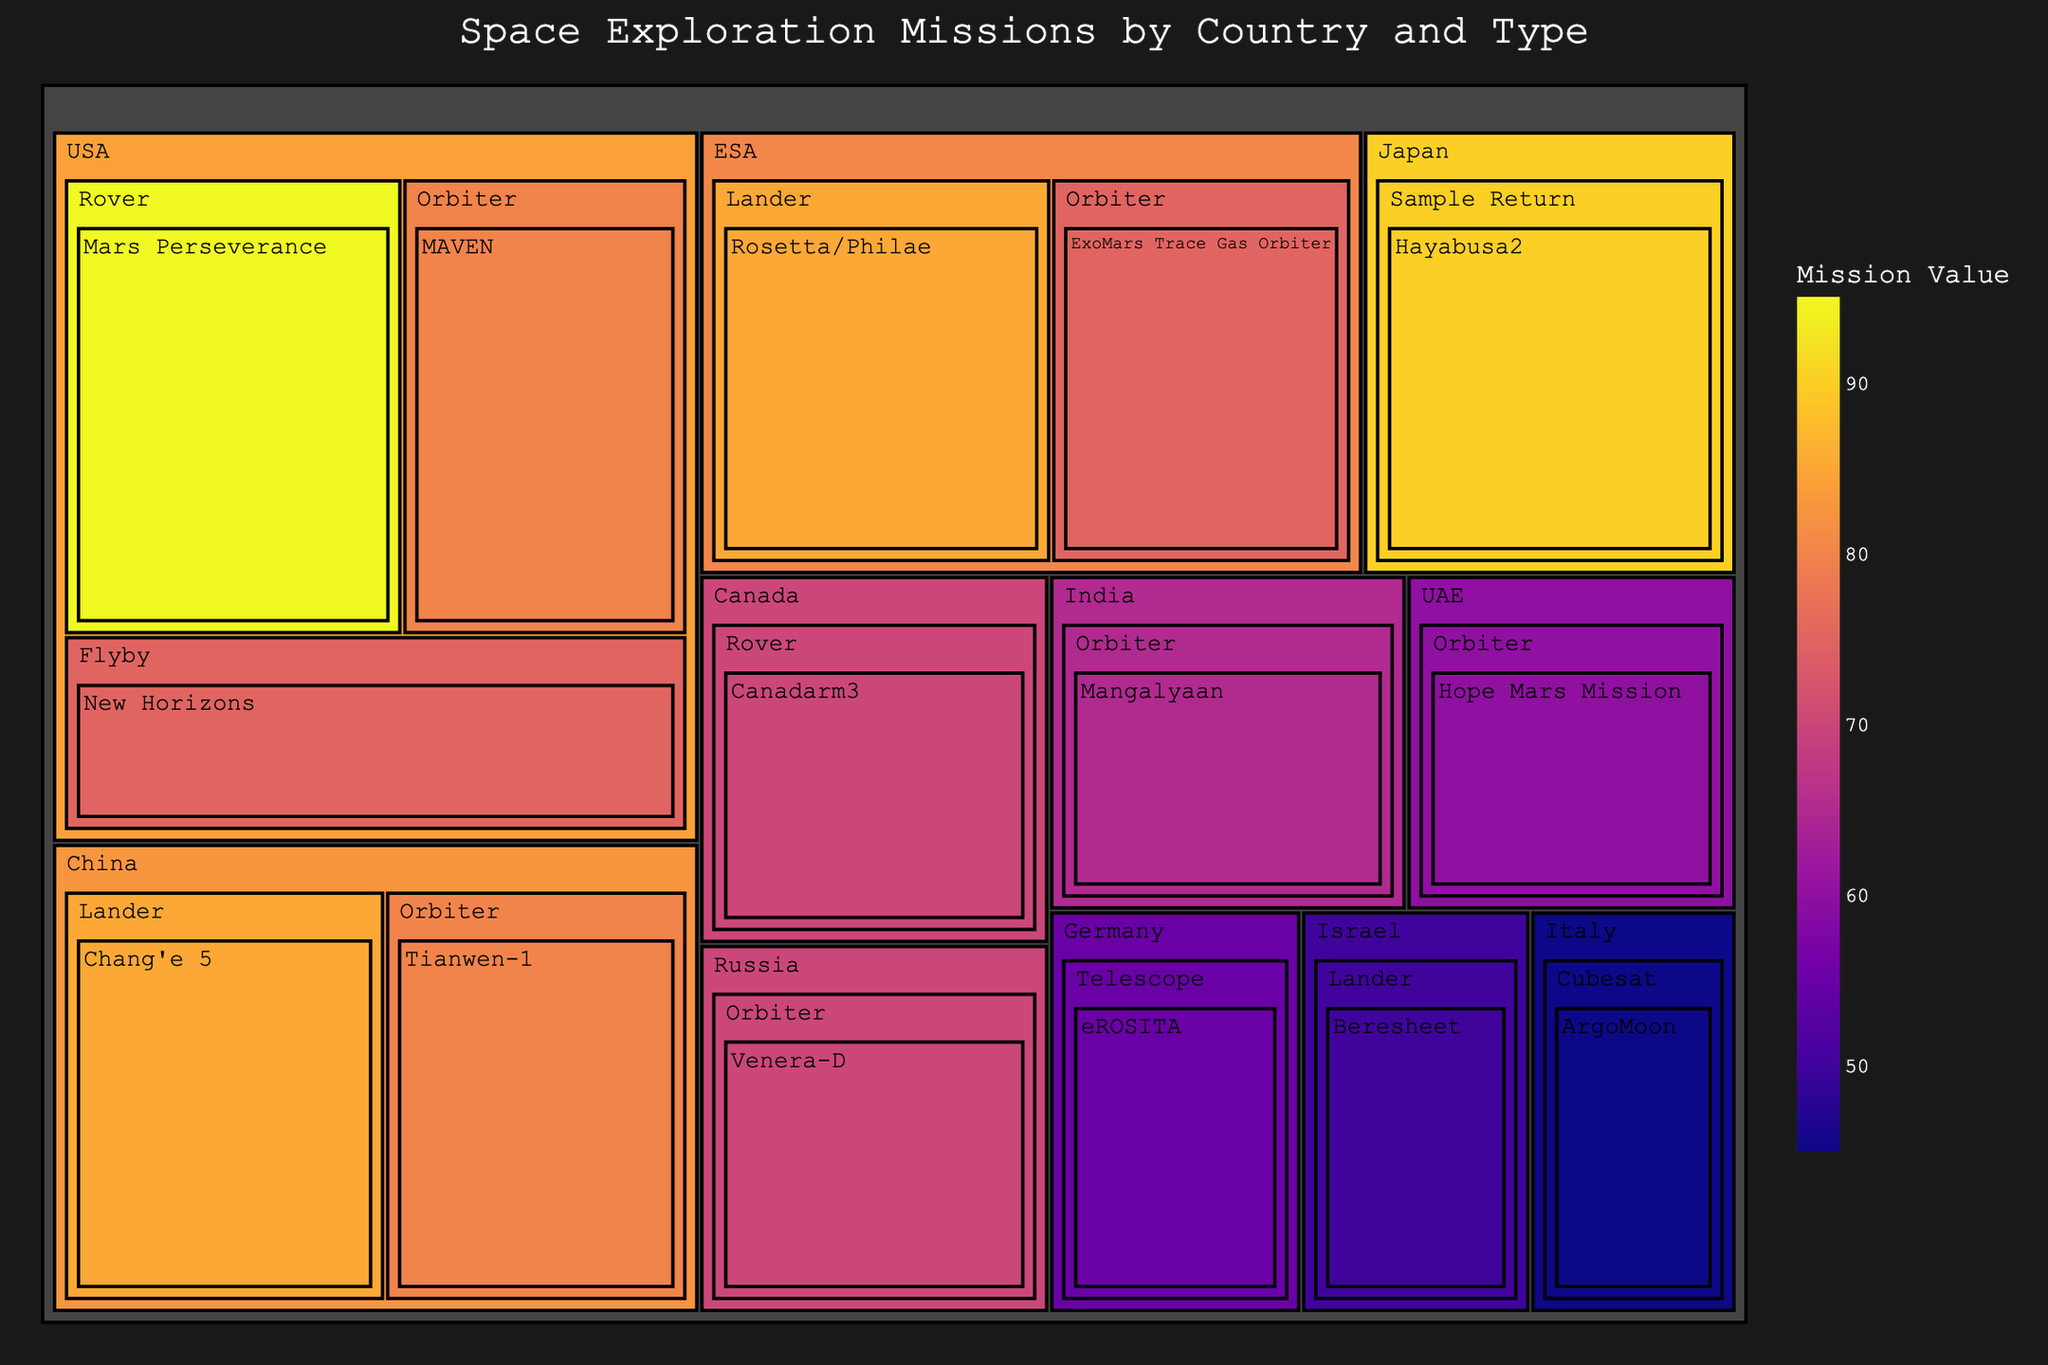what is the title of the treemap? The title is usually displayed prominently at the top of the treemap. The specified title in the code is 'Space Exploration Missions by Country and Type'.
Answer: Space Exploration Missions by Country and Type What country has the mission with the highest value? To identify the mission with the highest value, look at the boxes and their values, then find the corresponding country. The mission with the highest value is Mars Perseverance with 95 by the USA.
Answer: USA Which mission type has the highest total value for the USA? Sum values for each mission type under the USA. Rovers: 95; Orbiters: 80; Flybys: 75. The highest total is for Rovers with 95.
Answer: Rover What is the summed value of missions performed by ESA? Add up the values of all ESA missions. Rosetta/Philae (85) + ExoMars Trace Gas Orbiter (75). 85 + 75 = 160.
Answer: 160 Which mission types are conducted by both China and the USA? Identify the mission types listed under China and USA. Both have Orbiter missions.
Answer: Orbiter Compare the values of the Hayabusa2 mission and New Horizons mission. Which one is higher and by how much? Hayabusa2 has a value of 90 while New Horizons has a value of 75. The difference is 90 - 75 = 15, so Hayabusa2 is higher by 15.
Answer: Hayabusa2 by 15 What's the difference in value between India’s and UAE’s missions? Identify the values for India and UAE. India: Mangalyaan (65), UAE: Hope Mars Mission (60). The difference is 65 - 60 = 5.
Answer: 5 What are the types of missions coded to have a color closer to violet on the color scale? Missions with higher values are closer to violet on the Plasma color scale. Rover (USA) and Sample Return (Japan) missions have the highest values and thus the violet color.
Answer: Rover, Sample Return How many different countries have conducted Lander missions based on the treemap? Countries with Lander missions are listed: China (Chang'e 5), ESA (Rosetta/Philae), Israel (Beresheet). This sums to three.
Answer: 3 